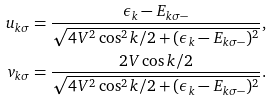Convert formula to latex. <formula><loc_0><loc_0><loc_500><loc_500>u _ { k \sigma } & = \frac { \epsilon _ { k } - E _ { k \sigma - } } { \sqrt { 4 V ^ { 2 } \cos ^ { 2 } { k } / 2 + ( \epsilon _ { k } - E _ { k \sigma - } ) ^ { 2 } } } , \\ v _ { k \sigma } & = \frac { 2 V \cos { k } / 2 } { \sqrt { 4 V ^ { 2 } \cos ^ { 2 } { k } / 2 + ( \epsilon _ { k } - E _ { k \sigma - } ) ^ { 2 } } } .</formula> 